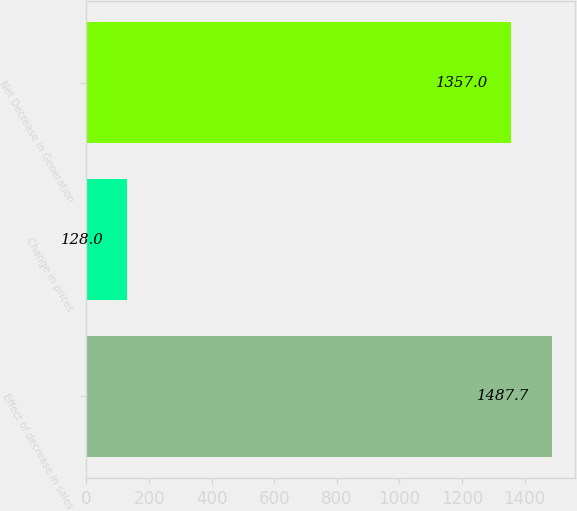Convert chart. <chart><loc_0><loc_0><loc_500><loc_500><bar_chart><fcel>Effect of decrease in sales<fcel>Change in prices<fcel>Net Decrease in Generation<nl><fcel>1487.7<fcel>128<fcel>1357<nl></chart> 